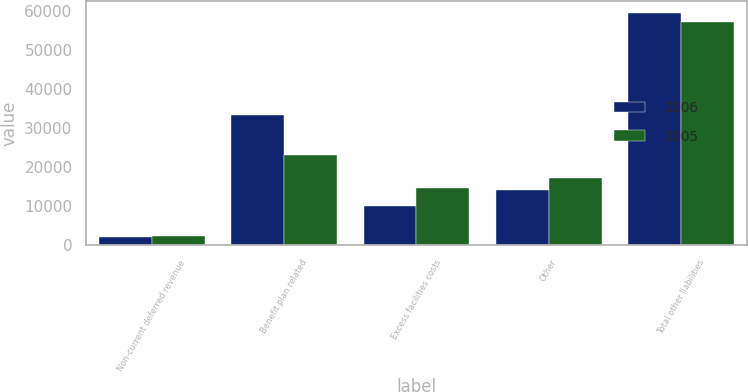Convert chart. <chart><loc_0><loc_0><loc_500><loc_500><stacked_bar_chart><ecel><fcel>Non-current deferred revenue<fcel>Benefit plan related<fcel>Excess facilities costs<fcel>Other<fcel>Total other liabilities<nl><fcel>2006<fcel>2148<fcel>33254<fcel>10134<fcel>14056<fcel>59592<nl><fcel>2005<fcel>2277<fcel>23074<fcel>14637<fcel>17273<fcel>57261<nl></chart> 